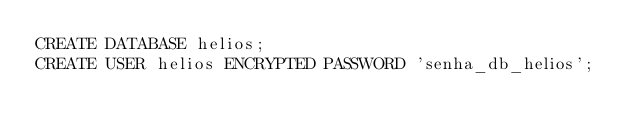<code> <loc_0><loc_0><loc_500><loc_500><_SQL_>CREATE DATABASE helios;
CREATE USER helios ENCRYPTED PASSWORD 'senha_db_helios';
</code> 